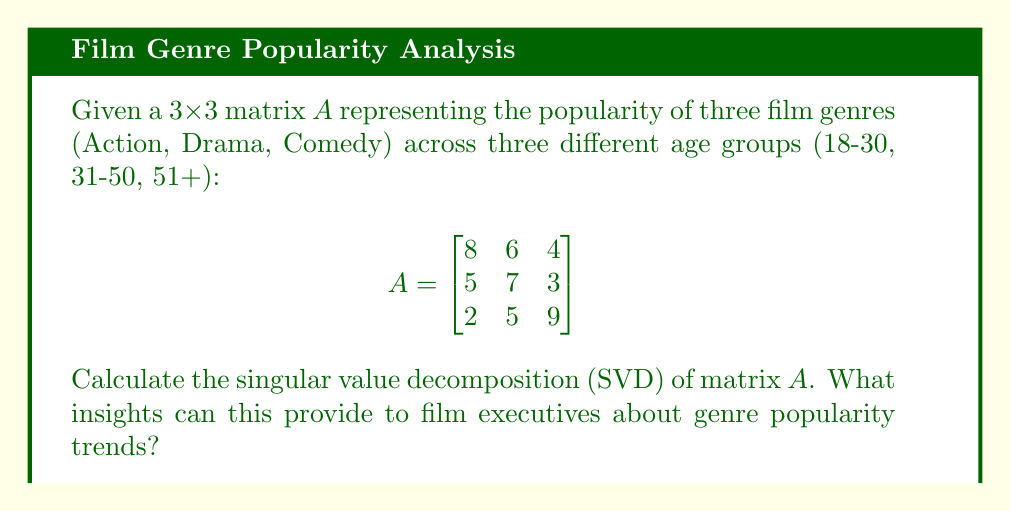Provide a solution to this math problem. To calculate the singular value decomposition (SVD) of matrix A, we need to find matrices U, Σ, and V such that A = UΣV^T, where U and V are orthogonal matrices and Σ is a diagonal matrix containing the singular values.

Step 1: Calculate A^T A and AA^T
$$A^T A = \begin{bmatrix}
93 & 89 & 65 \\
89 & 110 & 79 \\
65 & 79 & 106
\end{bmatrix}$$

$$AA^T = \begin{bmatrix}
116 & 94 & 58 \\
94 & 83 & 52 \\
58 & 52 & 110
\end{bmatrix}$$

Step 2: Find eigenvalues of A^T A (which are the square of singular values)
Characteristic equation: $\det(A^T A - \lambda I) = 0$
Solving this equation gives us:
$\lambda_1 \approx 250.39$, $\lambda_2 \approx 50.24$, $\lambda_3 \approx 8.37$

Step 3: Calculate singular values
$\sigma_1 = \sqrt{\lambda_1} \approx 15.82$
$\sigma_2 = \sqrt{\lambda_2} \approx 7.09$
$\sigma_3 = \sqrt{\lambda_3} \approx 2.89$

Step 4: Find eigenvectors of A^T A to form V
$$V \approx \begin{bmatrix}
-0.56 & -0.68 & -0.47 \\
-0.62 & 0.33 & 0.71 \\
-0.55 & 0.65 & -0.52
\end{bmatrix}$$

Step 5: Calculate U using U = AV/σ
$$U \approx \begin{bmatrix}
-0.64 & -0.63 & -0.44 \\
-0.55 & 0.21 & 0.81 \\
-0.53 & 0.75 & -0.39
\end{bmatrix}$$

Step 6: Form the diagonal matrix Σ
$$\Sigma = \begin{bmatrix}
15.82 & 0 & 0 \\
0 & 7.09 & 0 \\
0 & 0 & 2.89
\end{bmatrix}$$

Insights for film executives:
1. The first singular value (15.82) is significantly larger than the others, indicating a dominant trend in genre popularity across age groups.
2. The first column of U shows that this dominant trend is a mix of all genres, with slightly more weight on Action and Drama.
3. The first column of V suggests that this trend is relatively uniform across age groups, with slightly less influence from the 51+ group.
4. The second and third singular values represent less significant but still notable trends in genre preferences, which could be exploited for niche markets.
Answer: SVD: A = UΣV^T, where
U ≈ [[-0.64, -0.63, -0.44], [-0.55, 0.21, 0.81], [-0.53, 0.75, -0.39]]
Σ ≈ diag(15.82, 7.09, 2.89)
V^T ≈ [[-0.56, -0.62, -0.55], [-0.68, 0.33, 0.65], [-0.47, 0.71, -0.52]] 